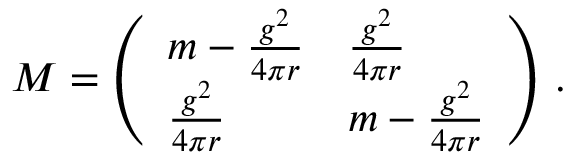<formula> <loc_0><loc_0><loc_500><loc_500>M = \left ( \begin{array} { l l } { { m - { \frac { g ^ { 2 } } { 4 \pi r } } } } & { { { \frac { g ^ { 2 } } { 4 \pi r } } } } \\ { { { \frac { g ^ { 2 } } { 4 \pi r } } } } & { { m - { \frac { g ^ { 2 } } { 4 \pi r } } } } \end{array} \right ) \, .</formula> 